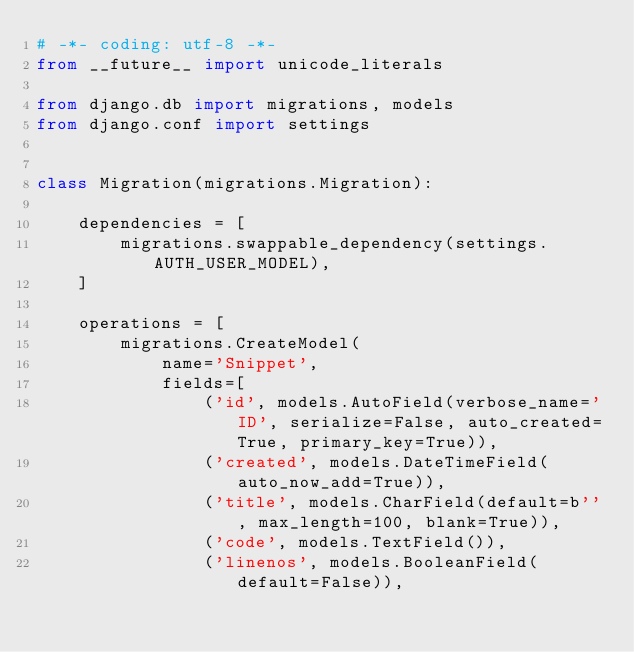<code> <loc_0><loc_0><loc_500><loc_500><_Python_># -*- coding: utf-8 -*-
from __future__ import unicode_literals

from django.db import migrations, models
from django.conf import settings


class Migration(migrations.Migration):

    dependencies = [
        migrations.swappable_dependency(settings.AUTH_USER_MODEL),
    ]

    operations = [
        migrations.CreateModel(
            name='Snippet',
            fields=[
                ('id', models.AutoField(verbose_name='ID', serialize=False, auto_created=True, primary_key=True)),
                ('created', models.DateTimeField(auto_now_add=True)),
                ('title', models.CharField(default=b'', max_length=100, blank=True)),
                ('code', models.TextField()),
                ('linenos', models.BooleanField(default=False)),</code> 